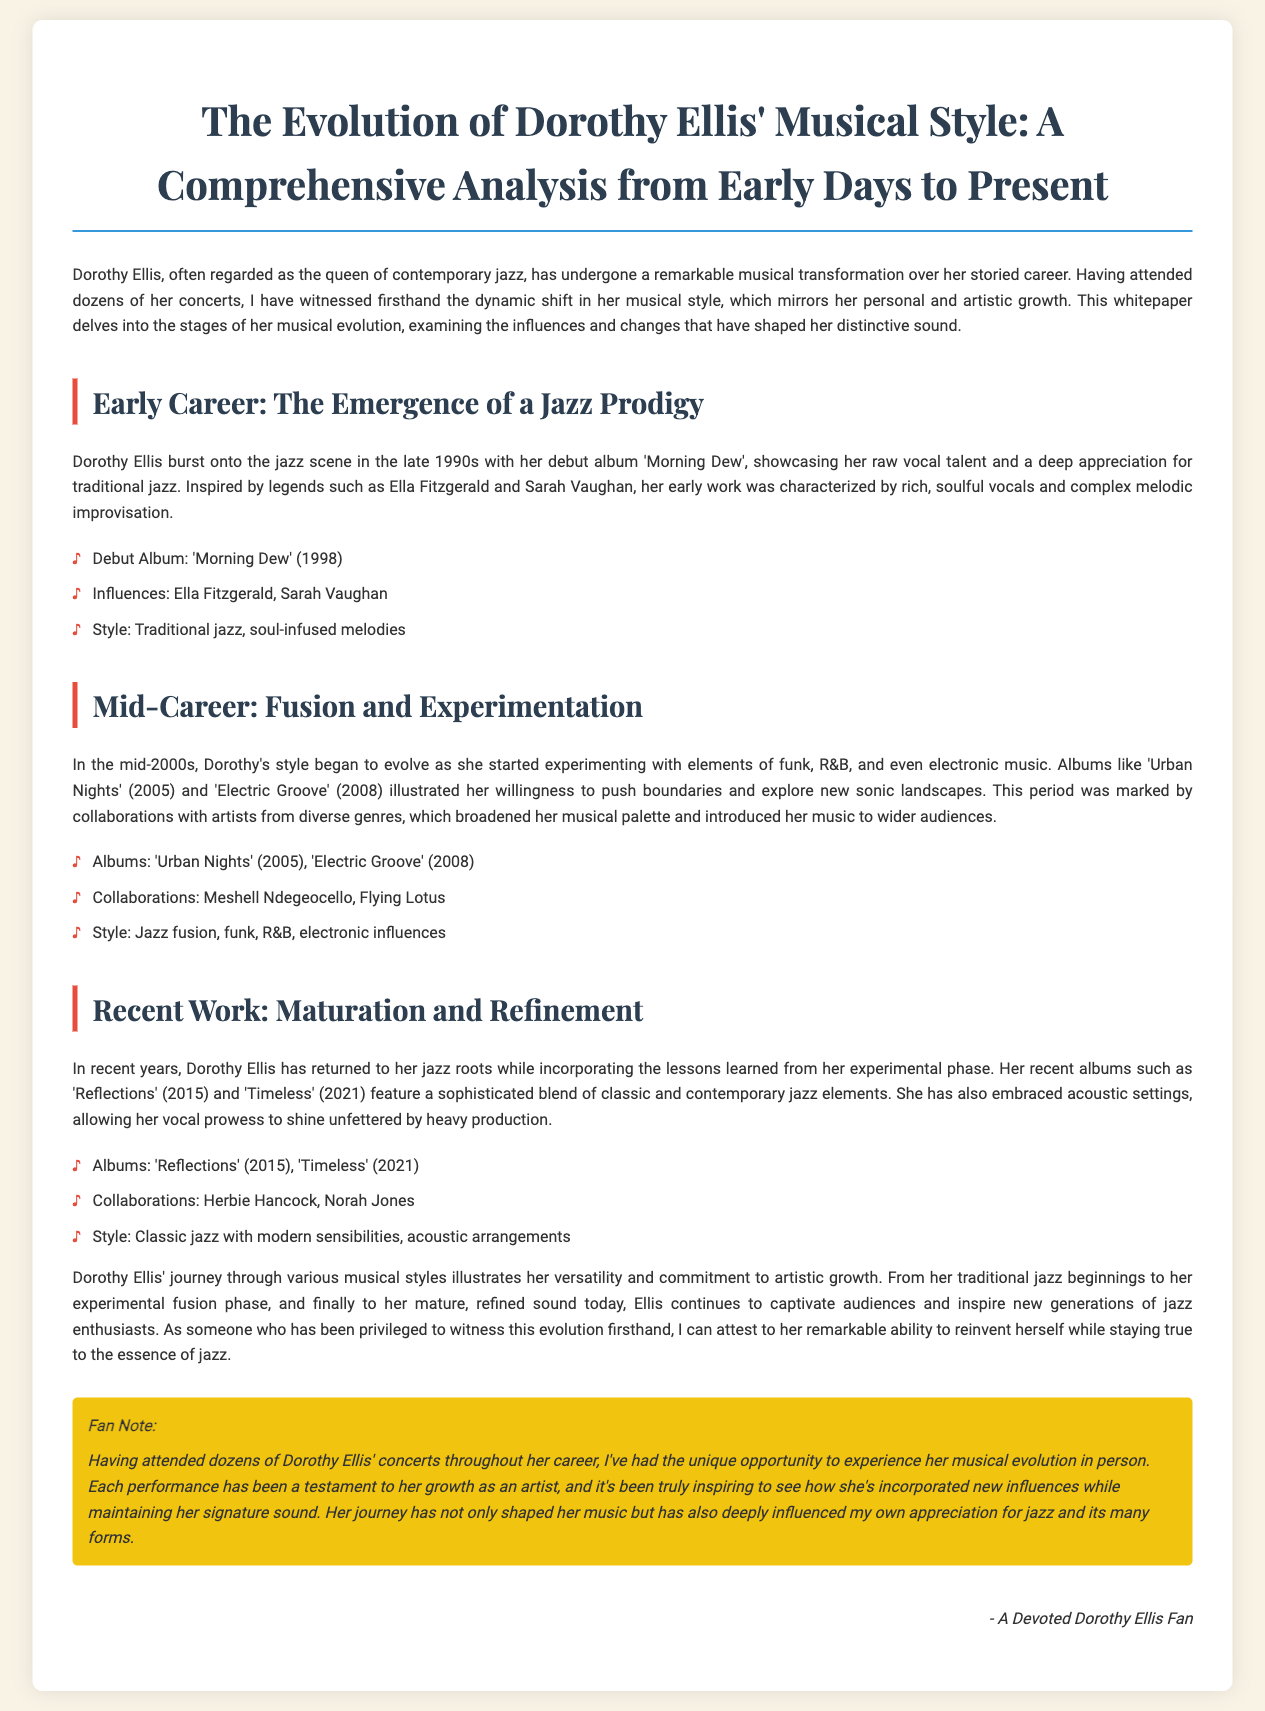What is the title of Dorothy Ellis' debut album? The title of Dorothy Ellis' debut album, as mentioned in the document, is 'Morning Dew'.
Answer: 'Morning Dew' In which year was 'Electric Groove' released? The document states that 'Electric Groove' was released in 2008.
Answer: 2008 Who are two artists Dorothy Ellis collaborated with during her mid-career? The document lists Meshell Ndegeocello and Flying Lotus as collaborators during her mid-career.
Answer: Meshell Ndegeocello, Flying Lotus What musical elements did Dorothy Ellis begin to experiment with in the mid-2000s? The document mentions that she experimented with funk, R&B, and electronic music during the mid-2000s.
Answer: Funk, R&B, electronic music What is the style of her recent albums 'Reflections' and 'Timeless'? The document describes the style of 'Reflections' and 'Timeless' as a blend of classic and contemporary jazz elements.
Answer: Classic and contemporary jazz In what decade did Dorothy Ellis emerge as a jazz artist? According to the document, Dorothy Ellis burst onto the jazz scene in the late 1990s.
Answer: Late 1990s What theme does the whitepaper predominantly focus on concerning Dorothy Ellis? The whitepaper predominantly focuses on the evolution of Dorothy Ellis' musical style throughout her career.
Answer: Evolution of musical style What personal experience does the author share in the fan note? The author shares their unique opportunity to experience Dorothy Ellis' musical evolution in person as a concert attendee.
Answer: Concert attendee experience 